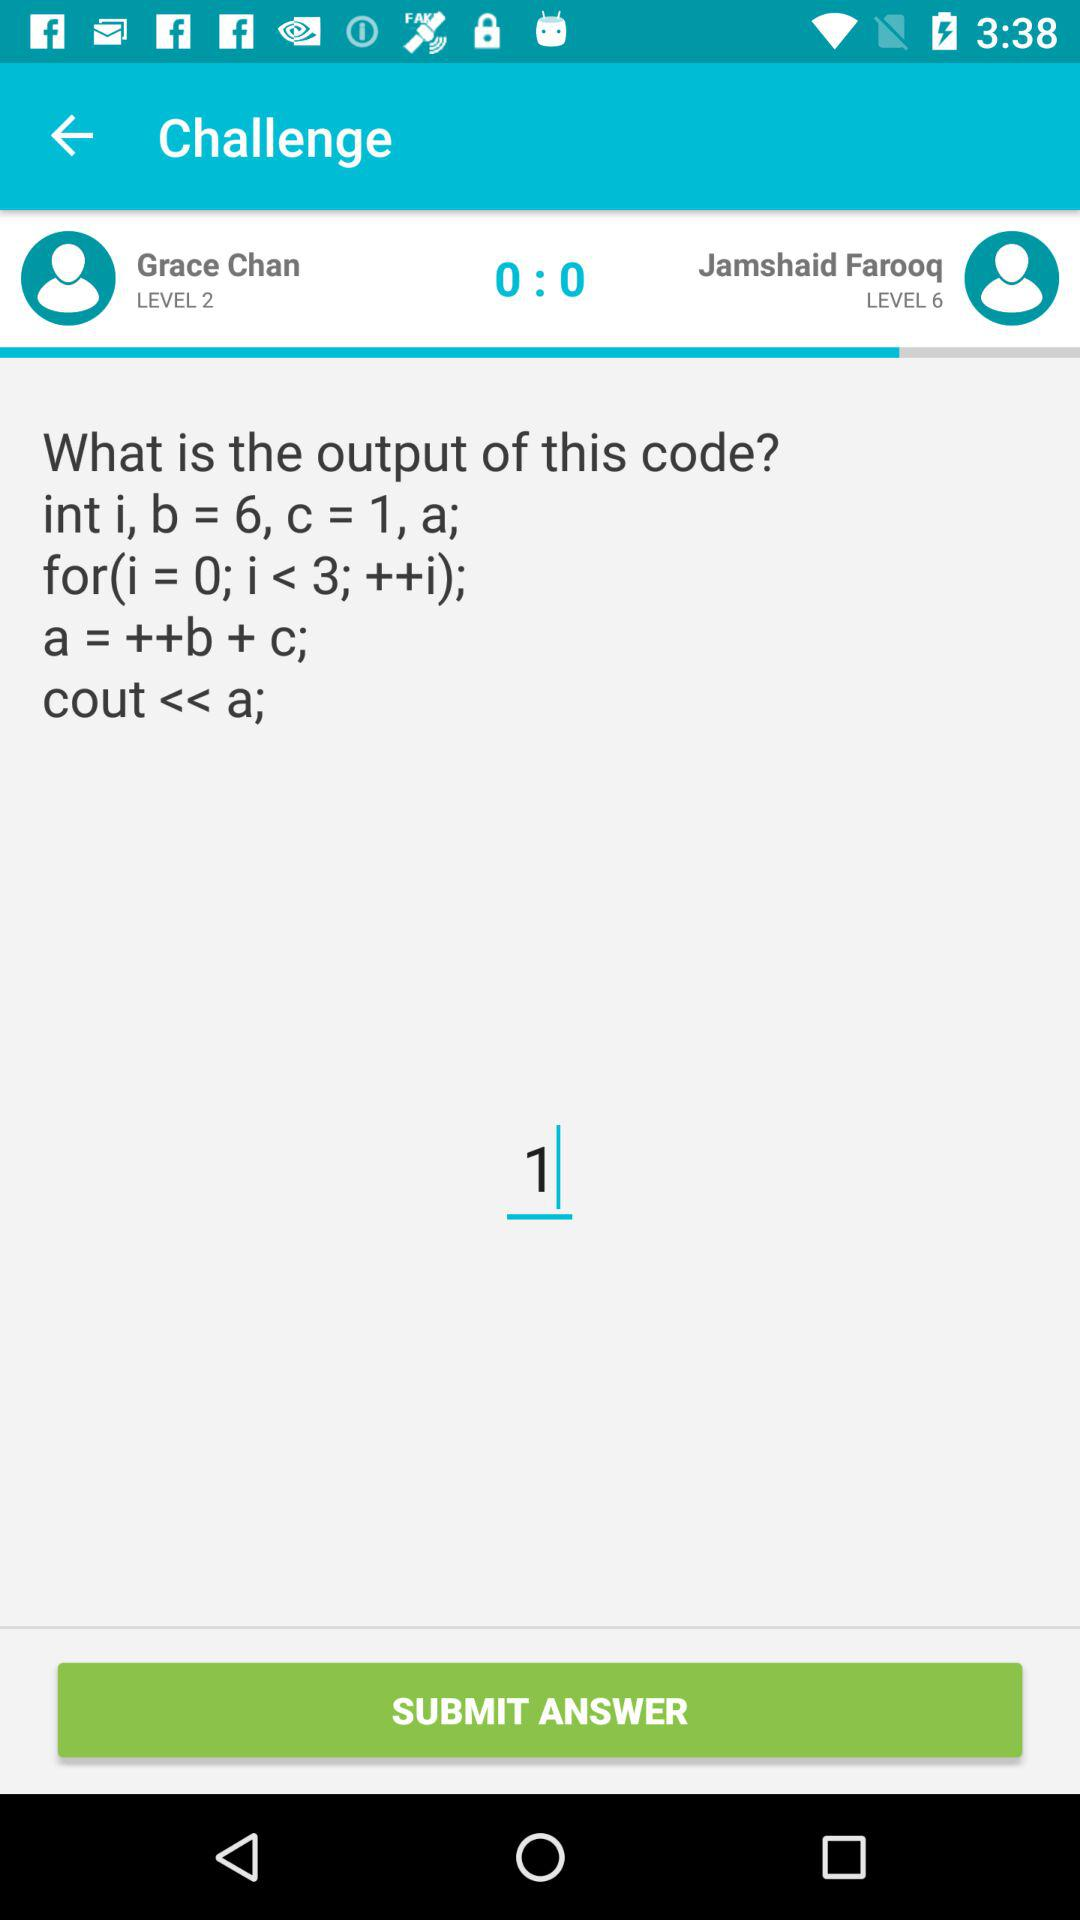What is the text entered in the text field? The text entered in the text field is 1. 